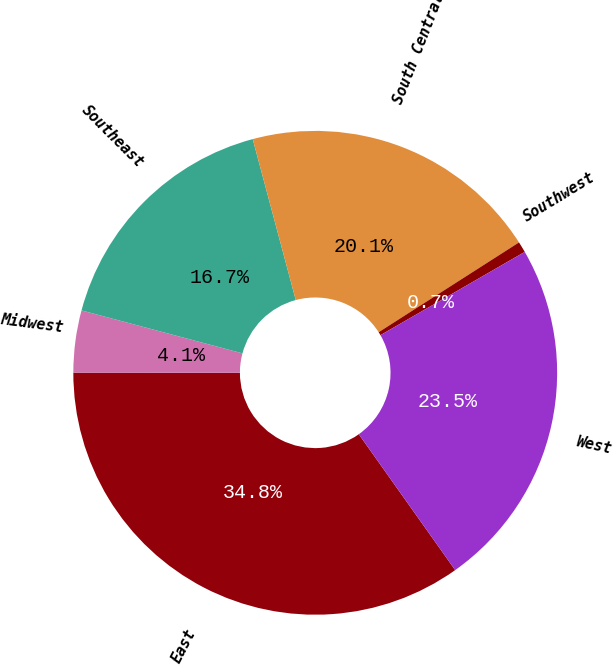Convert chart. <chart><loc_0><loc_0><loc_500><loc_500><pie_chart><fcel>East<fcel>Midwest<fcel>Southeast<fcel>South Central<fcel>Southwest<fcel>West<nl><fcel>34.83%<fcel>4.14%<fcel>16.69%<fcel>20.1%<fcel>0.73%<fcel>23.51%<nl></chart> 